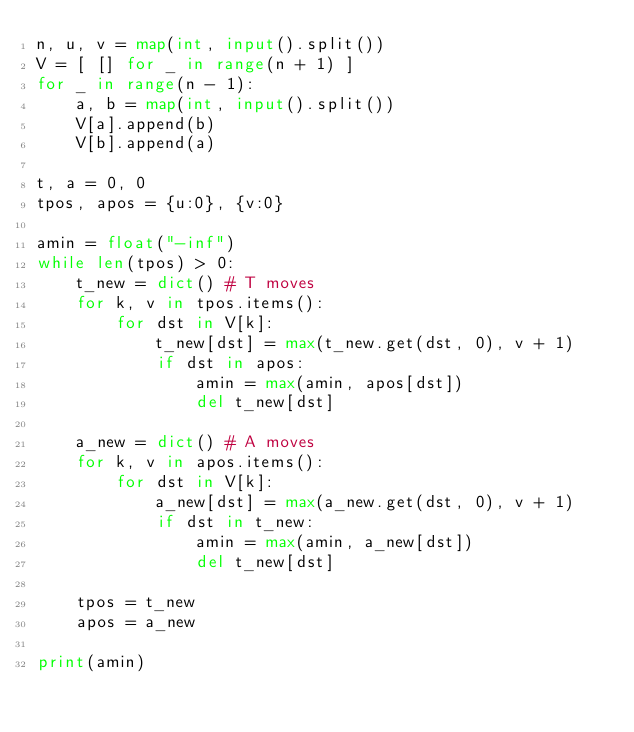<code> <loc_0><loc_0><loc_500><loc_500><_Python_>n, u, v = map(int, input().split())
V = [ [] for _ in range(n + 1) ]
for _ in range(n - 1):
    a, b = map(int, input().split())
    V[a].append(b)
    V[b].append(a)

t, a = 0, 0
tpos, apos = {u:0}, {v:0}

amin = float("-inf")
while len(tpos) > 0:
    t_new = dict() # T moves                                                                                                                            
    for k, v in tpos.items():
        for dst in V[k]:
            t_new[dst] = max(t_new.get(dst, 0), v + 1)
            if dst in apos:
                amin = max(amin, apos[dst])
                del t_new[dst]

    a_new = dict() # A moves                                                                                                                            
    for k, v in apos.items():
        for dst in V[k]:
            a_new[dst] = max(a_new.get(dst, 0), v + 1)
            if dst in t_new:
                amin = max(amin, a_new[dst])
                del t_new[dst]

    tpos = t_new
    apos = a_new

print(amin)
</code> 